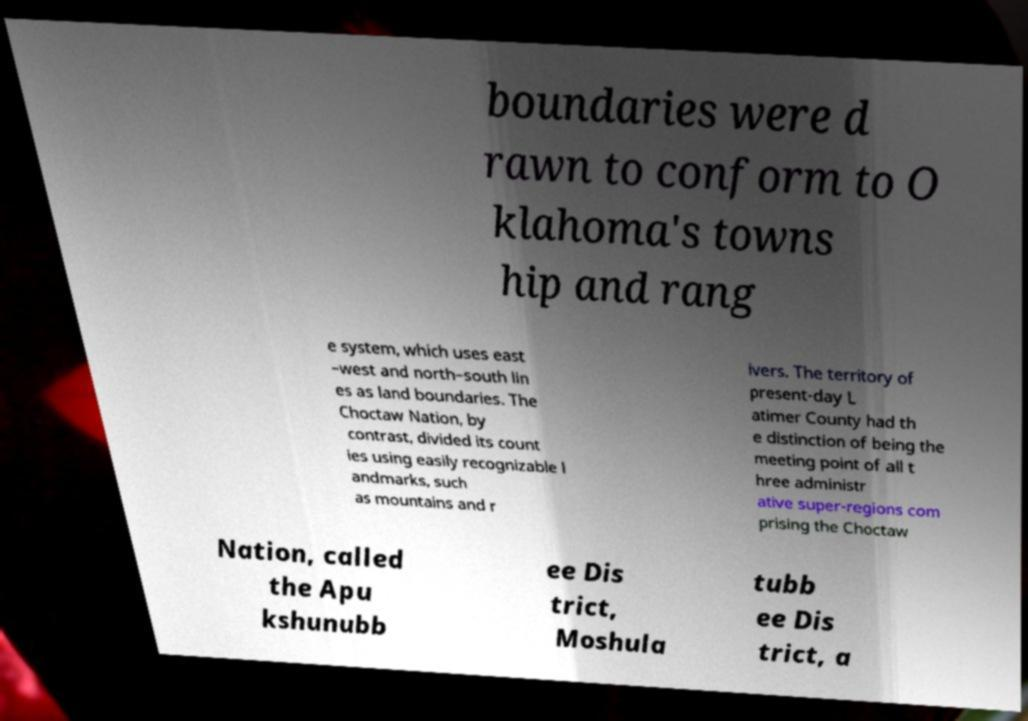What messages or text are displayed in this image? I need them in a readable, typed format. boundaries were d rawn to conform to O klahoma's towns hip and rang e system, which uses east –west and north–south lin es as land boundaries. The Choctaw Nation, by contrast, divided its count ies using easily recognizable l andmarks, such as mountains and r ivers. The territory of present-day L atimer County had th e distinction of being the meeting point of all t hree administr ative super-regions com prising the Choctaw Nation, called the Apu kshunubb ee Dis trict, Moshula tubb ee Dis trict, a 